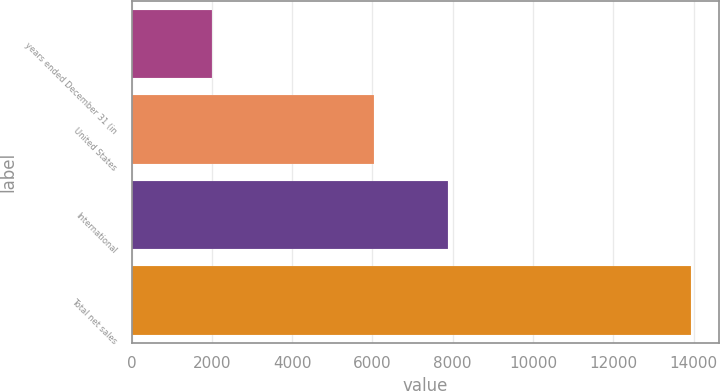Convert chart. <chart><loc_0><loc_0><loc_500><loc_500><bar_chart><fcel>years ended December 31 (in<fcel>United States<fcel>International<fcel>Total net sales<nl><fcel>2012<fcel>6043<fcel>7893<fcel>13936<nl></chart> 